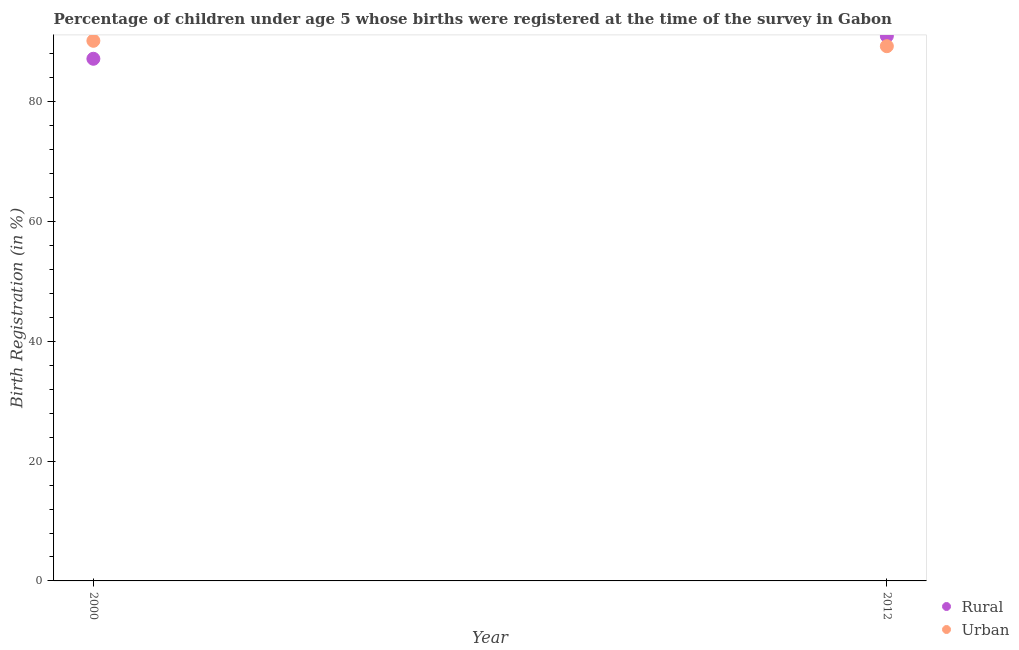Is the number of dotlines equal to the number of legend labels?
Keep it short and to the point. Yes. What is the rural birth registration in 2000?
Your answer should be very brief. 87.2. Across all years, what is the maximum urban birth registration?
Offer a very short reply. 90.2. Across all years, what is the minimum rural birth registration?
Your answer should be very brief. 87.2. What is the total urban birth registration in the graph?
Ensure brevity in your answer.  179.5. What is the difference between the rural birth registration in 2000 and that in 2012?
Offer a terse response. -3.8. What is the difference between the rural birth registration in 2012 and the urban birth registration in 2000?
Provide a short and direct response. 0.8. What is the average urban birth registration per year?
Offer a very short reply. 89.75. In the year 2012, what is the difference between the urban birth registration and rural birth registration?
Your answer should be very brief. -1.7. In how many years, is the rural birth registration greater than 44 %?
Offer a terse response. 2. What is the ratio of the rural birth registration in 2000 to that in 2012?
Provide a short and direct response. 0.96. Is the rural birth registration in 2000 less than that in 2012?
Your answer should be compact. Yes. Does the rural birth registration monotonically increase over the years?
Ensure brevity in your answer.  Yes. Is the urban birth registration strictly less than the rural birth registration over the years?
Make the answer very short. No. What is the difference between two consecutive major ticks on the Y-axis?
Provide a succinct answer. 20. Are the values on the major ticks of Y-axis written in scientific E-notation?
Your answer should be compact. No. Where does the legend appear in the graph?
Offer a terse response. Bottom right. How many legend labels are there?
Offer a terse response. 2. What is the title of the graph?
Give a very brief answer. Percentage of children under age 5 whose births were registered at the time of the survey in Gabon. What is the label or title of the Y-axis?
Provide a succinct answer. Birth Registration (in %). What is the Birth Registration (in %) of Rural in 2000?
Offer a very short reply. 87.2. What is the Birth Registration (in %) in Urban in 2000?
Offer a terse response. 90.2. What is the Birth Registration (in %) of Rural in 2012?
Provide a succinct answer. 91. What is the Birth Registration (in %) in Urban in 2012?
Provide a short and direct response. 89.3. Across all years, what is the maximum Birth Registration (in %) in Rural?
Your answer should be compact. 91. Across all years, what is the maximum Birth Registration (in %) in Urban?
Your answer should be compact. 90.2. Across all years, what is the minimum Birth Registration (in %) of Rural?
Give a very brief answer. 87.2. Across all years, what is the minimum Birth Registration (in %) in Urban?
Provide a succinct answer. 89.3. What is the total Birth Registration (in %) in Rural in the graph?
Provide a succinct answer. 178.2. What is the total Birth Registration (in %) of Urban in the graph?
Provide a short and direct response. 179.5. What is the difference between the Birth Registration (in %) of Rural in 2000 and that in 2012?
Your answer should be very brief. -3.8. What is the difference between the Birth Registration (in %) of Rural in 2000 and the Birth Registration (in %) of Urban in 2012?
Make the answer very short. -2.1. What is the average Birth Registration (in %) of Rural per year?
Your response must be concise. 89.1. What is the average Birth Registration (in %) of Urban per year?
Offer a very short reply. 89.75. In the year 2000, what is the difference between the Birth Registration (in %) in Rural and Birth Registration (in %) in Urban?
Your answer should be compact. -3. In the year 2012, what is the difference between the Birth Registration (in %) in Rural and Birth Registration (in %) in Urban?
Keep it short and to the point. 1.7. What is the ratio of the Birth Registration (in %) of Rural in 2000 to that in 2012?
Offer a very short reply. 0.96. What is the difference between the highest and the second highest Birth Registration (in %) of Urban?
Offer a very short reply. 0.9. What is the difference between the highest and the lowest Birth Registration (in %) of Rural?
Your answer should be compact. 3.8. What is the difference between the highest and the lowest Birth Registration (in %) in Urban?
Offer a very short reply. 0.9. 